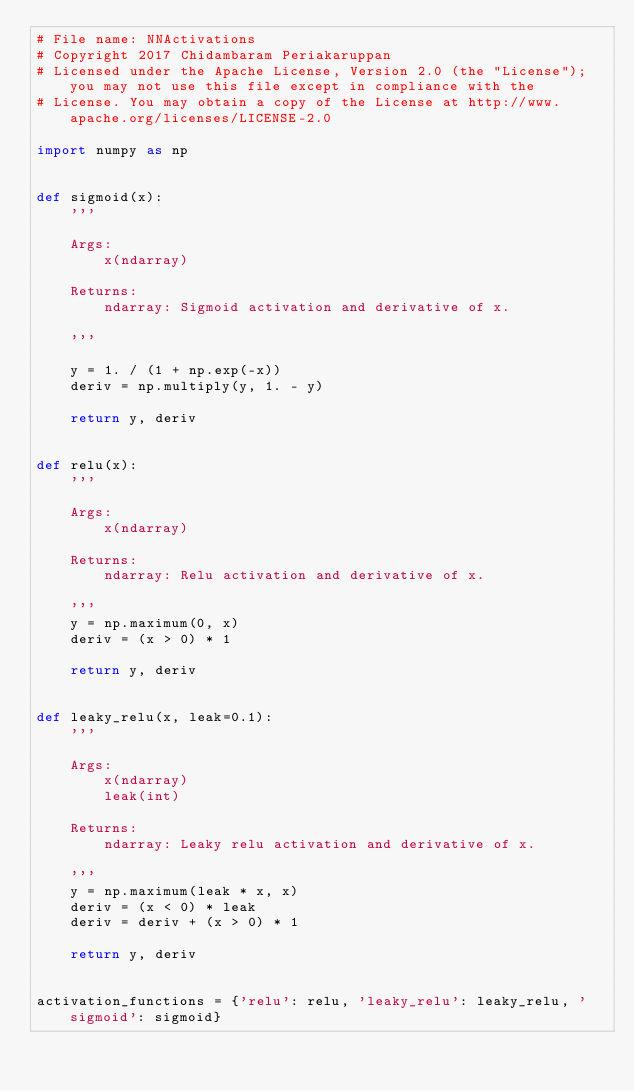<code> <loc_0><loc_0><loc_500><loc_500><_Python_># File name: NNActivations
# Copyright 2017 Chidambaram Periakaruppan
# Licensed under the Apache License, Version 2.0 (the "License"); you may not use this file except in compliance with the
# License. You may obtain a copy of the License at http://www.apache.org/licenses/LICENSE-2.0

import numpy as np


def sigmoid(x):
    '''

    Args:
        x(ndarray)

    Returns:
        ndarray: Sigmoid activation and derivative of x.

    '''

    y = 1. / (1 + np.exp(-x))
    deriv = np.multiply(y, 1. - y)

    return y, deriv


def relu(x):
    '''

    Args:
        x(ndarray)

    Returns:
        ndarray: Relu activation and derivative of x.

    '''
    y = np.maximum(0, x)
    deriv = (x > 0) * 1

    return y, deriv


def leaky_relu(x, leak=0.1):
    '''

    Args:
        x(ndarray)
        leak(int)

    Returns:
        ndarray: Leaky relu activation and derivative of x.

    '''
    y = np.maximum(leak * x, x)
    deriv = (x < 0) * leak
    deriv = deriv + (x > 0) * 1

    return y, deriv


activation_functions = {'relu': relu, 'leaky_relu': leaky_relu, 'sigmoid': sigmoid}
</code> 